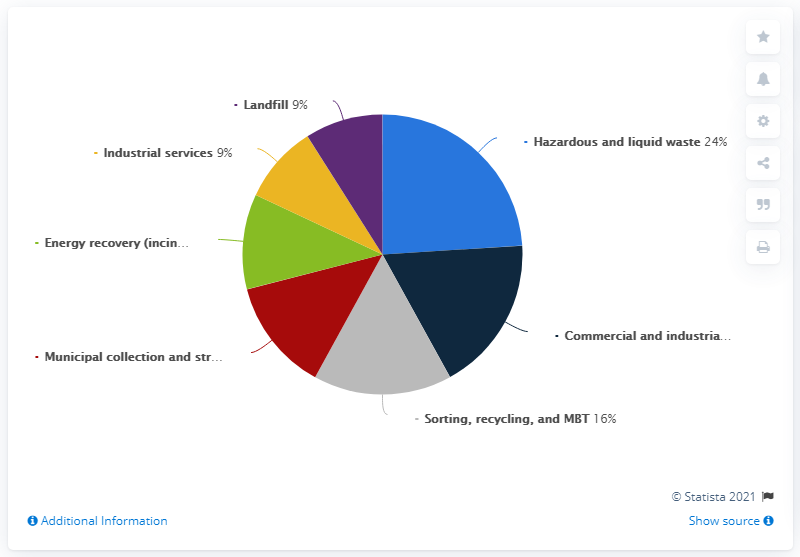Identify some key points in this picture. The sum of industrial services and landfill is 18. Hazardous and liquid waste represents 24% of the activity. In 2021, approximately 24% of Veolia's waste revenue was generated from hazardous and liquid waste activities. 